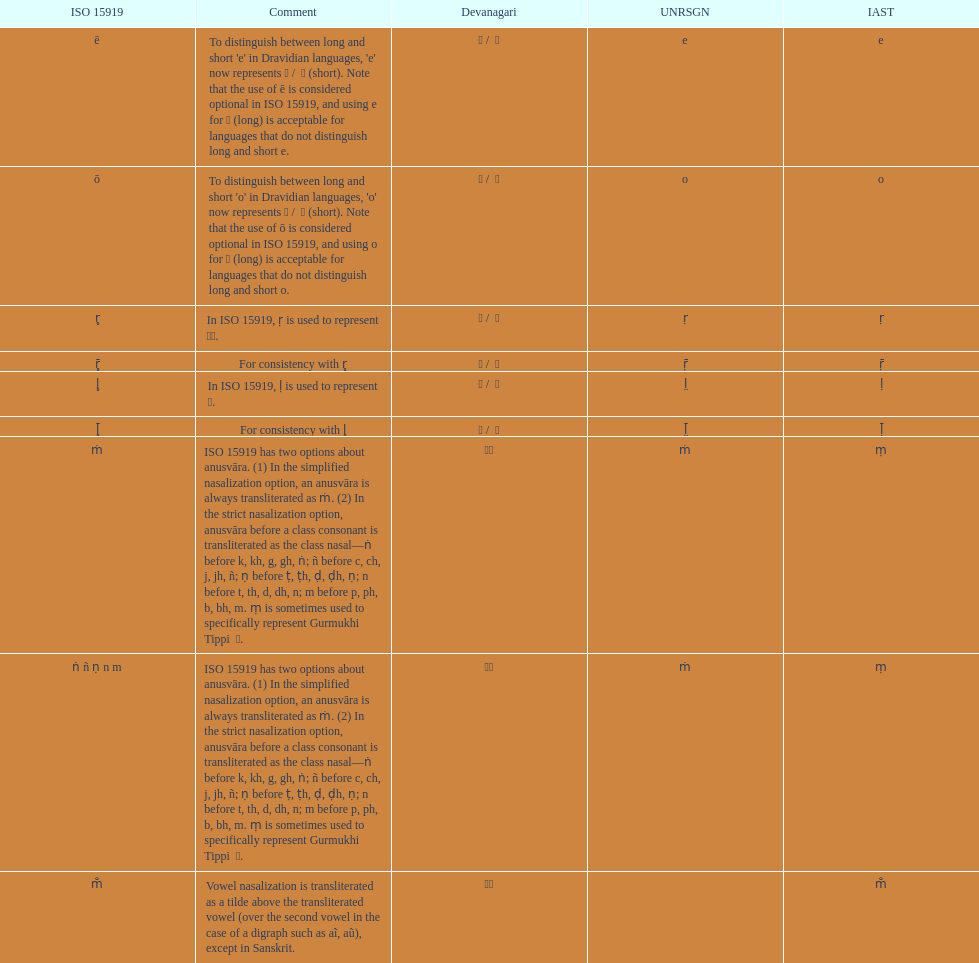What is listed previous to in iso 15919, &#7735; is used to represent &#2355;. under comments? For consistency with r̥. Could you help me parse every detail presented in this table? {'header': ['ISO 15919', 'Comment', 'Devanagari', 'UNRSGN', 'IAST'], 'rows': [['ē', "To distinguish between long and short 'e' in Dravidian languages, 'e' now represents ऎ / \xa0ॆ (short). Note that the use of ē is considered optional in ISO 15919, and using e for ए (long) is acceptable for languages that do not distinguish long and short e.", 'ए / \xa0े', 'e', 'e'], ['ō', "To distinguish between long and short 'o' in Dravidian languages, 'o' now represents ऒ / \xa0ॊ (short). Note that the use of ō is considered optional in ISO 15919, and using o for ओ (long) is acceptable for languages that do not distinguish long and short o.", 'ओ / \xa0ो', 'o', 'o'], ['r̥', 'In ISO 15919, ṛ is used to represent ड़.', 'ऋ / \xa0ृ', 'ṛ', 'ṛ'], ['r̥̄', 'For consistency with r̥', 'ॠ / \xa0ॄ', 'ṝ', 'ṝ'], ['l̥', 'In ISO 15919, ḷ is used to represent ळ.', 'ऌ / \xa0ॢ', 'l̤', 'ḷ'], ['l̥̄', 'For consistency with l̥', 'ॡ / \xa0ॣ', 'l̤̄', 'ḹ'], ['ṁ', 'ISO 15919 has two options about anusvāra. (1) In the simplified nasalization option, an anusvāra is always transliterated as ṁ. (2) In the strict nasalization option, anusvāra before a class consonant is transliterated as the class nasal—ṅ before k, kh, g, gh, ṅ; ñ before c, ch, j, jh, ñ; ṇ before ṭ, ṭh, ḍ, ḍh, ṇ; n before t, th, d, dh, n; m before p, ph, b, bh, m. ṃ is sometimes used to specifically represent Gurmukhi Tippi \xa0ੰ.', '◌ं', 'ṁ', 'ṃ'], ['ṅ ñ ṇ n m', 'ISO 15919 has two options about anusvāra. (1) In the simplified nasalization option, an anusvāra is always transliterated as ṁ. (2) In the strict nasalization option, anusvāra before a class consonant is transliterated as the class nasal—ṅ before k, kh, g, gh, ṅ; ñ before c, ch, j, jh, ñ; ṇ before ṭ, ṭh, ḍ, ḍh, ṇ; n before t, th, d, dh, n; m before p, ph, b, bh, m. ṃ is sometimes used to specifically represent Gurmukhi Tippi \xa0ੰ.', '◌ं', 'ṁ', 'ṃ'], ['m̐', 'Vowel nasalization is transliterated as a tilde above the transliterated vowel (over the second vowel in the case of a digraph such as aĩ, aũ), except in Sanskrit.', '◌ँ', '', 'm̐']]} 